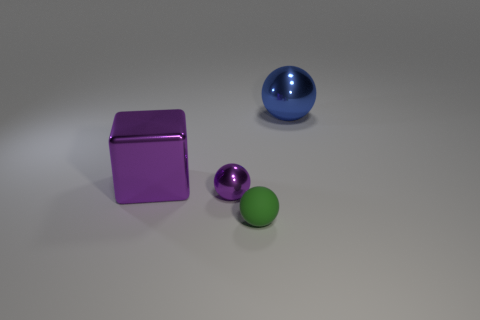Add 3 big blue shiny spheres. How many objects exist? 7 Subtract all balls. How many objects are left? 1 Subtract all brown rubber objects. Subtract all shiny objects. How many objects are left? 1 Add 1 tiny green spheres. How many tiny green spheres are left? 2 Add 2 green spheres. How many green spheres exist? 3 Subtract 1 purple cubes. How many objects are left? 3 